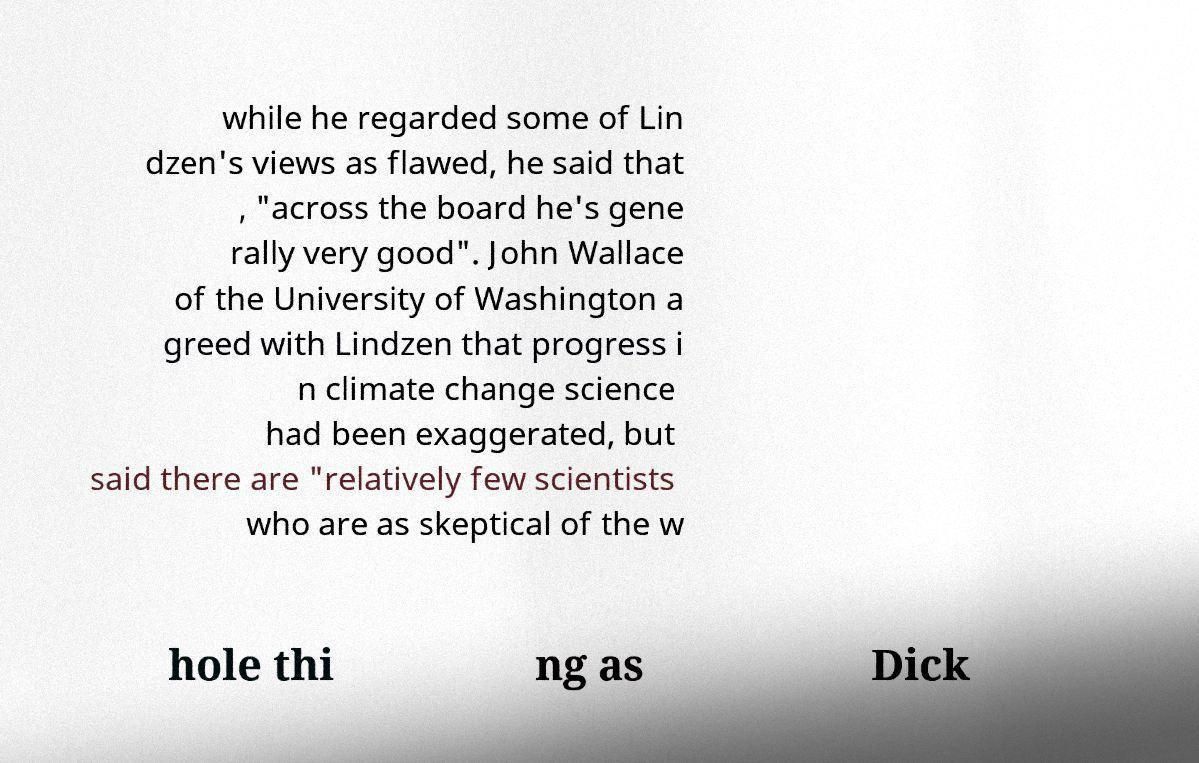I need the written content from this picture converted into text. Can you do that? while he regarded some of Lin dzen's views as flawed, he said that , "across the board he's gene rally very good". John Wallace of the University of Washington a greed with Lindzen that progress i n climate change science had been exaggerated, but said there are "relatively few scientists who are as skeptical of the w hole thi ng as Dick 